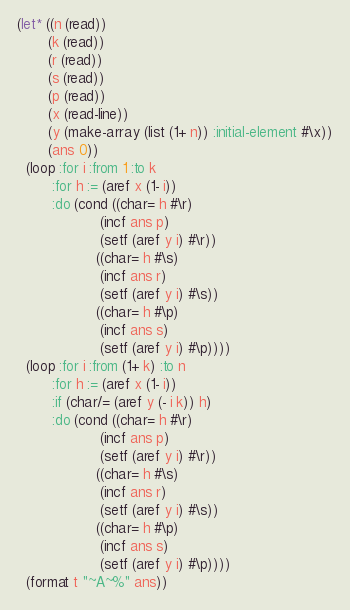Convert code to text. <code><loc_0><loc_0><loc_500><loc_500><_Lisp_>(let* ((n (read))
       (k (read))
       (r (read))
       (s (read))
       (p (read))
       (x (read-line))
       (y (make-array (list (1+ n)) :initial-element #\x))
       (ans 0))
  (loop :for i :from 1 :to k
        :for h := (aref x (1- i))
        :do (cond ((char= h #\r)
                   (incf ans p)
                   (setf (aref y i) #\r))
                  ((char= h #\s)
                   (incf ans r)
                   (setf (aref y i) #\s))
                  ((char= h #\p)
                   (incf ans s)
                   (setf (aref y i) #\p))))
  (loop :for i :from (1+ k) :to n
        :for h := (aref x (1- i))
        :if (char/= (aref y (- i k)) h)
        :do (cond ((char= h #\r)
                   (incf ans p)
                   (setf (aref y i) #\r))
                  ((char= h #\s)
                   (incf ans r)
                   (setf (aref y i) #\s))
                  ((char= h #\p)
                   (incf ans s)
                   (setf (aref y i) #\p))))
  (format t "~A~%" ans))
</code> 